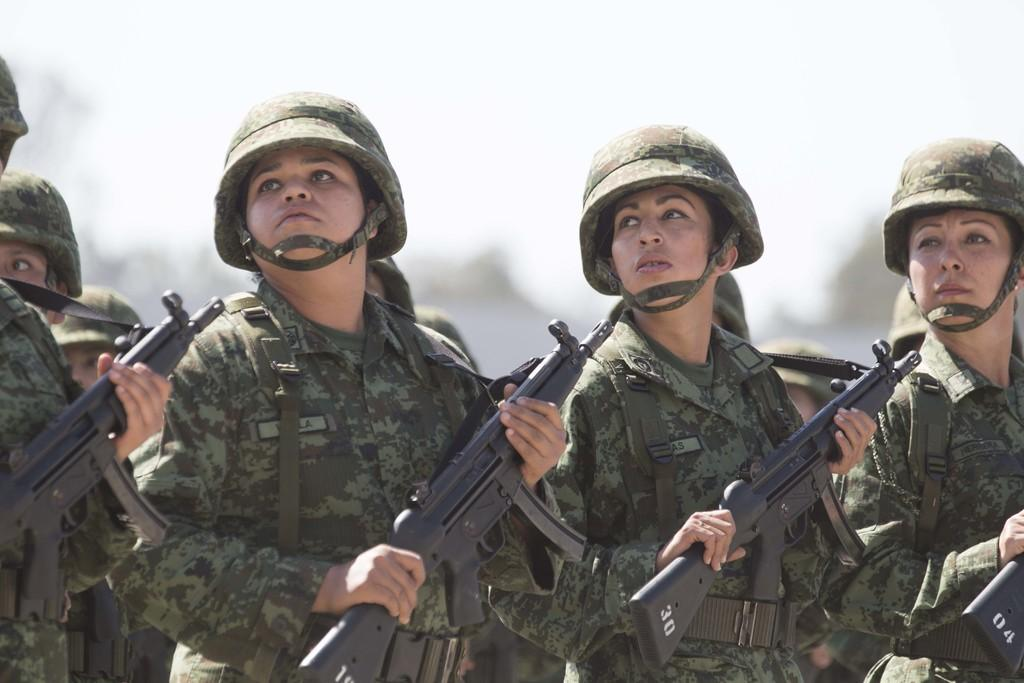What is the main subject of the image? The main subject of the image is a group of people. What are the people in the image doing? The people are standing and holding guns. Can you describe the background of the image? The background of the image is blurry. Where is the shelf with copies of the book located in the image? There is no shelf or copies of a book present in the image; it features a group of people standing and holding guns. What type of beetle can be seen crawling on the ground in the image? There is no beetle present in the image. 